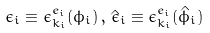Convert formula to latex. <formula><loc_0><loc_0><loc_500><loc_500>\epsilon _ { i } \equiv \epsilon _ { { k } _ { i } } ^ { e _ { i } } ( \phi _ { i } ) \, , \, \hat { \epsilon } _ { i } \equiv \epsilon _ { { k } _ { i } } ^ { e _ { i } } ( \hat { \phi } _ { i } )</formula> 